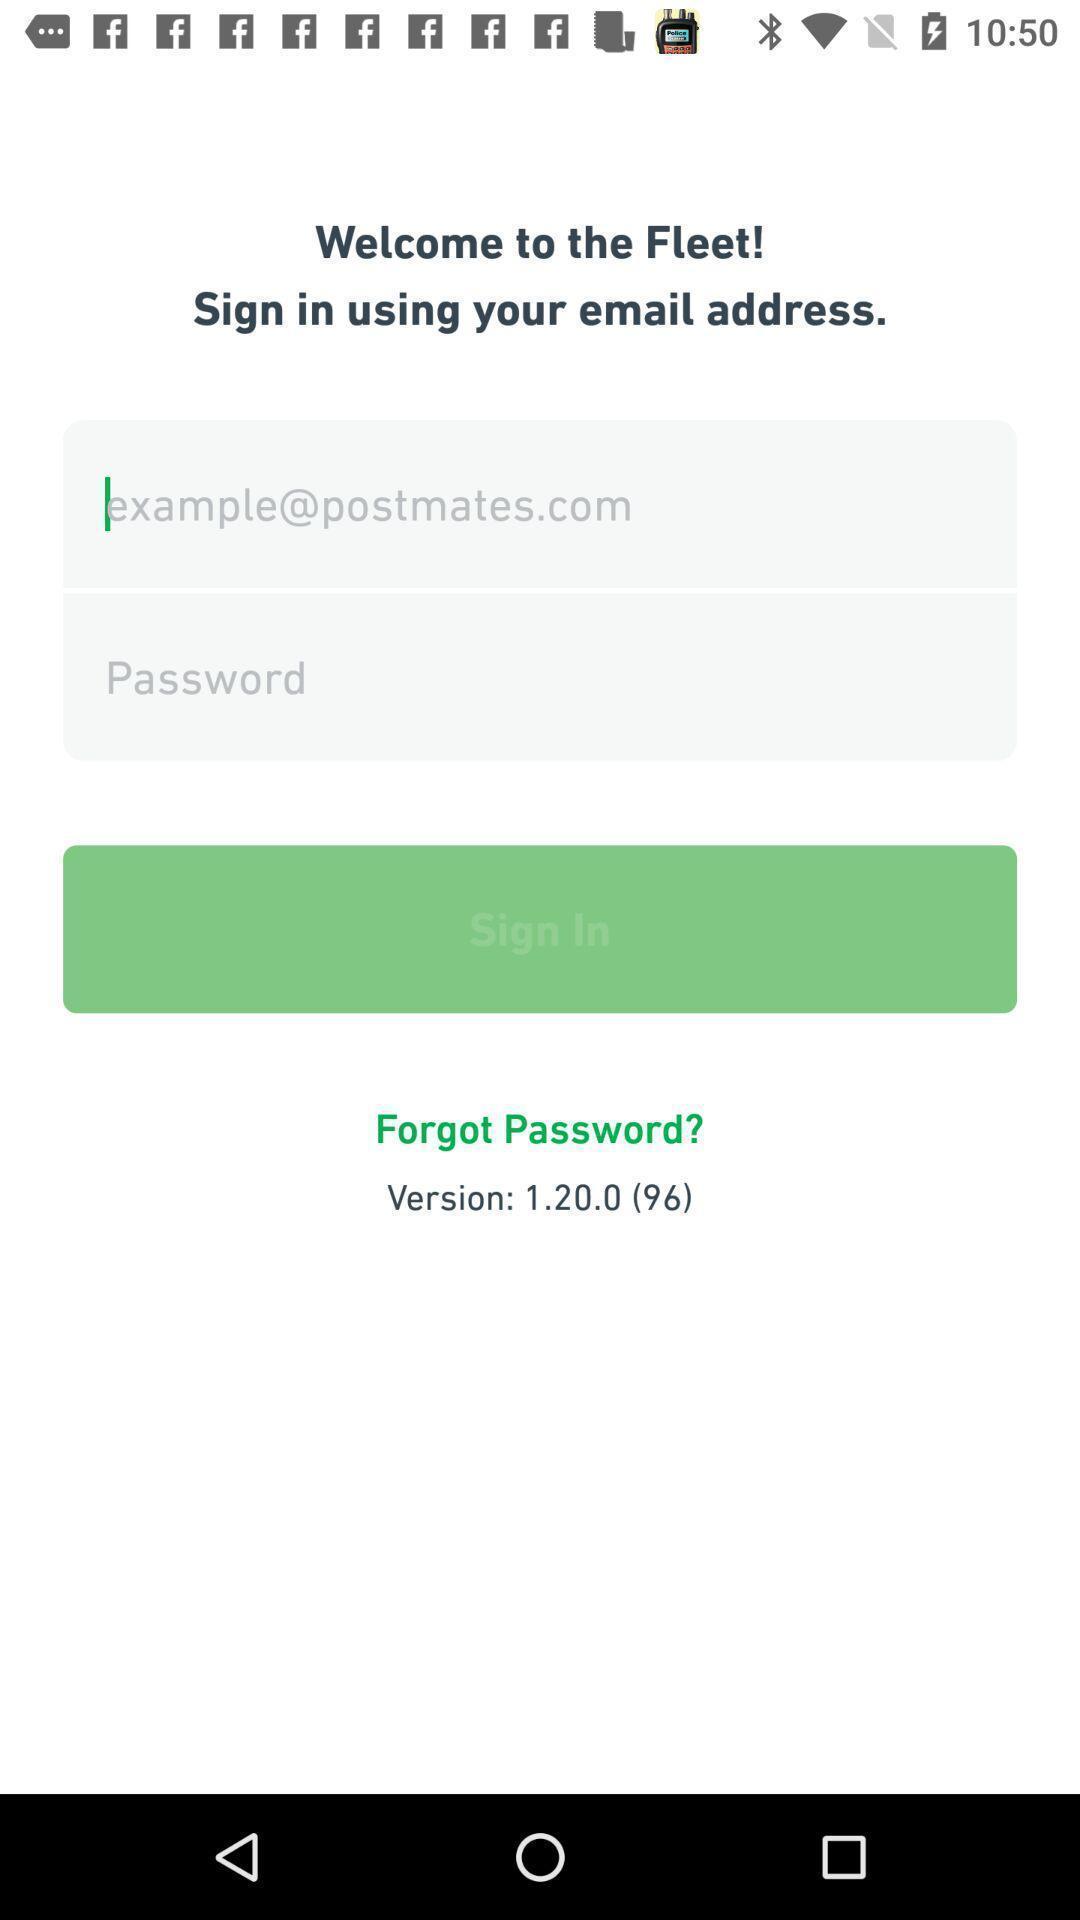Describe the visual elements of this screenshot. Welcoming page a social app. 